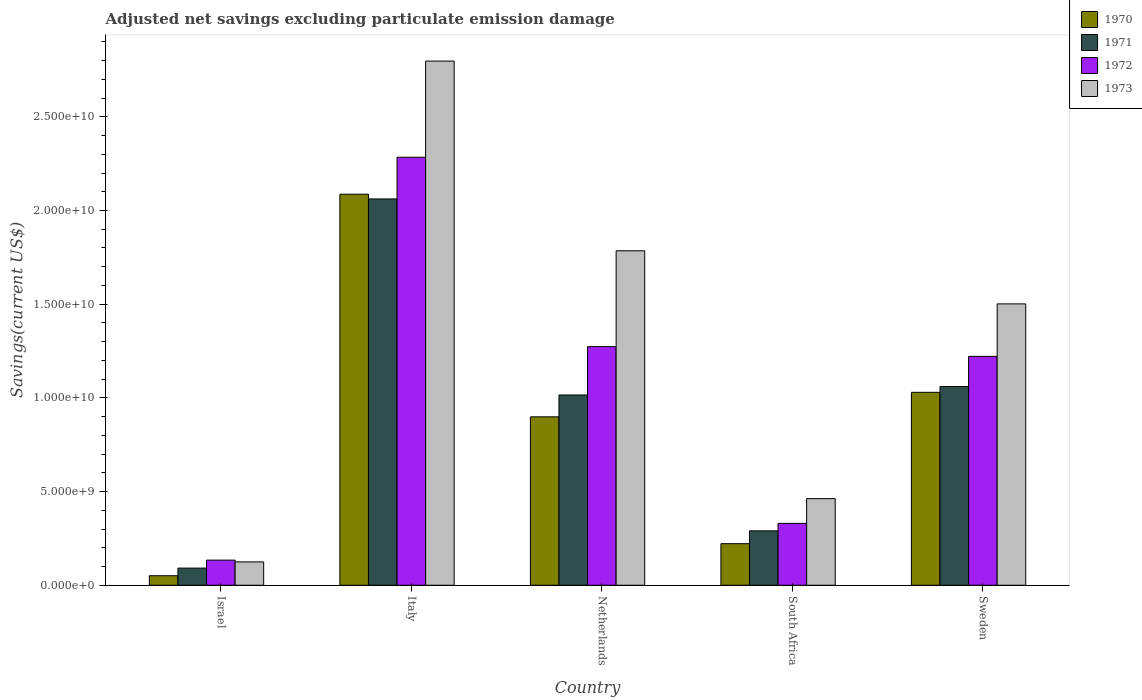How many different coloured bars are there?
Your answer should be compact. 4. How many groups of bars are there?
Your response must be concise. 5. Are the number of bars on each tick of the X-axis equal?
Make the answer very short. Yes. How many bars are there on the 1st tick from the left?
Provide a short and direct response. 4. How many bars are there on the 5th tick from the right?
Offer a very short reply. 4. What is the adjusted net savings in 1972 in South Africa?
Keep it short and to the point. 3.30e+09. Across all countries, what is the maximum adjusted net savings in 1971?
Your answer should be very brief. 2.06e+1. Across all countries, what is the minimum adjusted net savings in 1972?
Provide a short and direct response. 1.34e+09. In which country was the adjusted net savings in 1970 maximum?
Make the answer very short. Italy. In which country was the adjusted net savings in 1973 minimum?
Offer a terse response. Israel. What is the total adjusted net savings in 1972 in the graph?
Provide a short and direct response. 5.24e+1. What is the difference between the adjusted net savings in 1971 in Israel and that in Italy?
Make the answer very short. -1.97e+1. What is the difference between the adjusted net savings in 1970 in Sweden and the adjusted net savings in 1971 in Netherlands?
Ensure brevity in your answer.  1.43e+08. What is the average adjusted net savings in 1970 per country?
Make the answer very short. 8.58e+09. What is the difference between the adjusted net savings of/in 1972 and adjusted net savings of/in 1973 in Italy?
Your answer should be compact. -5.13e+09. In how many countries, is the adjusted net savings in 1970 greater than 13000000000 US$?
Ensure brevity in your answer.  1. What is the ratio of the adjusted net savings in 1970 in Italy to that in Sweden?
Your answer should be compact. 2.03. Is the difference between the adjusted net savings in 1972 in Italy and Sweden greater than the difference between the adjusted net savings in 1973 in Italy and Sweden?
Your answer should be compact. No. What is the difference between the highest and the second highest adjusted net savings in 1972?
Provide a succinct answer. -1.06e+1. What is the difference between the highest and the lowest adjusted net savings in 1973?
Offer a terse response. 2.67e+1. Is the sum of the adjusted net savings in 1972 in Italy and South Africa greater than the maximum adjusted net savings in 1971 across all countries?
Your response must be concise. Yes. Is it the case that in every country, the sum of the adjusted net savings in 1972 and adjusted net savings in 1970 is greater than the sum of adjusted net savings in 1973 and adjusted net savings in 1971?
Provide a succinct answer. No. What does the 3rd bar from the right in Israel represents?
Provide a short and direct response. 1971. How many bars are there?
Provide a succinct answer. 20. How many countries are there in the graph?
Ensure brevity in your answer.  5. What is the difference between two consecutive major ticks on the Y-axis?
Provide a short and direct response. 5.00e+09. Does the graph contain any zero values?
Provide a succinct answer. No. What is the title of the graph?
Make the answer very short. Adjusted net savings excluding particulate emission damage. Does "2001" appear as one of the legend labels in the graph?
Your response must be concise. No. What is the label or title of the Y-axis?
Make the answer very short. Savings(current US$). What is the Savings(current US$) in 1970 in Israel?
Give a very brief answer. 5.08e+08. What is the Savings(current US$) of 1971 in Israel?
Make the answer very short. 9.14e+08. What is the Savings(current US$) in 1972 in Israel?
Provide a short and direct response. 1.34e+09. What is the Savings(current US$) in 1973 in Israel?
Your answer should be very brief. 1.25e+09. What is the Savings(current US$) of 1970 in Italy?
Provide a succinct answer. 2.09e+1. What is the Savings(current US$) in 1971 in Italy?
Ensure brevity in your answer.  2.06e+1. What is the Savings(current US$) of 1972 in Italy?
Your response must be concise. 2.28e+1. What is the Savings(current US$) in 1973 in Italy?
Your answer should be very brief. 2.80e+1. What is the Savings(current US$) in 1970 in Netherlands?
Provide a short and direct response. 8.99e+09. What is the Savings(current US$) of 1971 in Netherlands?
Provide a succinct answer. 1.02e+1. What is the Savings(current US$) in 1972 in Netherlands?
Make the answer very short. 1.27e+1. What is the Savings(current US$) in 1973 in Netherlands?
Your answer should be very brief. 1.79e+1. What is the Savings(current US$) in 1970 in South Africa?
Keep it short and to the point. 2.22e+09. What is the Savings(current US$) in 1971 in South Africa?
Offer a terse response. 2.90e+09. What is the Savings(current US$) of 1972 in South Africa?
Make the answer very short. 3.30e+09. What is the Savings(current US$) of 1973 in South Africa?
Offer a very short reply. 4.62e+09. What is the Savings(current US$) of 1970 in Sweden?
Offer a terse response. 1.03e+1. What is the Savings(current US$) in 1971 in Sweden?
Offer a very short reply. 1.06e+1. What is the Savings(current US$) in 1972 in Sweden?
Make the answer very short. 1.22e+1. What is the Savings(current US$) in 1973 in Sweden?
Offer a very short reply. 1.50e+1. Across all countries, what is the maximum Savings(current US$) of 1970?
Provide a succinct answer. 2.09e+1. Across all countries, what is the maximum Savings(current US$) of 1971?
Your answer should be very brief. 2.06e+1. Across all countries, what is the maximum Savings(current US$) of 1972?
Offer a very short reply. 2.28e+1. Across all countries, what is the maximum Savings(current US$) in 1973?
Give a very brief answer. 2.80e+1. Across all countries, what is the minimum Savings(current US$) in 1970?
Provide a succinct answer. 5.08e+08. Across all countries, what is the minimum Savings(current US$) of 1971?
Provide a succinct answer. 9.14e+08. Across all countries, what is the minimum Savings(current US$) in 1972?
Your response must be concise. 1.34e+09. Across all countries, what is the minimum Savings(current US$) in 1973?
Your answer should be compact. 1.25e+09. What is the total Savings(current US$) in 1970 in the graph?
Your response must be concise. 4.29e+1. What is the total Savings(current US$) of 1971 in the graph?
Provide a short and direct response. 4.52e+1. What is the total Savings(current US$) in 1972 in the graph?
Ensure brevity in your answer.  5.24e+1. What is the total Savings(current US$) of 1973 in the graph?
Provide a short and direct response. 6.67e+1. What is the difference between the Savings(current US$) of 1970 in Israel and that in Italy?
Ensure brevity in your answer.  -2.04e+1. What is the difference between the Savings(current US$) in 1971 in Israel and that in Italy?
Keep it short and to the point. -1.97e+1. What is the difference between the Savings(current US$) of 1972 in Israel and that in Italy?
Your response must be concise. -2.15e+1. What is the difference between the Savings(current US$) of 1973 in Israel and that in Italy?
Provide a short and direct response. -2.67e+1. What is the difference between the Savings(current US$) of 1970 in Israel and that in Netherlands?
Offer a very short reply. -8.48e+09. What is the difference between the Savings(current US$) of 1971 in Israel and that in Netherlands?
Your response must be concise. -9.24e+09. What is the difference between the Savings(current US$) of 1972 in Israel and that in Netherlands?
Offer a very short reply. -1.14e+1. What is the difference between the Savings(current US$) in 1973 in Israel and that in Netherlands?
Your answer should be very brief. -1.66e+1. What is the difference between the Savings(current US$) of 1970 in Israel and that in South Africa?
Your response must be concise. -1.71e+09. What is the difference between the Savings(current US$) of 1971 in Israel and that in South Africa?
Provide a succinct answer. -1.99e+09. What is the difference between the Savings(current US$) of 1972 in Israel and that in South Africa?
Offer a terse response. -1.96e+09. What is the difference between the Savings(current US$) of 1973 in Israel and that in South Africa?
Make the answer very short. -3.38e+09. What is the difference between the Savings(current US$) in 1970 in Israel and that in Sweden?
Provide a short and direct response. -9.79e+09. What is the difference between the Savings(current US$) of 1971 in Israel and that in Sweden?
Your answer should be very brief. -9.69e+09. What is the difference between the Savings(current US$) in 1972 in Israel and that in Sweden?
Offer a very short reply. -1.09e+1. What is the difference between the Savings(current US$) of 1973 in Israel and that in Sweden?
Provide a short and direct response. -1.38e+1. What is the difference between the Savings(current US$) of 1970 in Italy and that in Netherlands?
Provide a short and direct response. 1.19e+1. What is the difference between the Savings(current US$) in 1971 in Italy and that in Netherlands?
Your answer should be very brief. 1.05e+1. What is the difference between the Savings(current US$) in 1972 in Italy and that in Netherlands?
Your answer should be very brief. 1.01e+1. What is the difference between the Savings(current US$) of 1973 in Italy and that in Netherlands?
Offer a very short reply. 1.01e+1. What is the difference between the Savings(current US$) of 1970 in Italy and that in South Africa?
Keep it short and to the point. 1.87e+1. What is the difference between the Savings(current US$) of 1971 in Italy and that in South Africa?
Ensure brevity in your answer.  1.77e+1. What is the difference between the Savings(current US$) of 1972 in Italy and that in South Africa?
Your answer should be compact. 1.95e+1. What is the difference between the Savings(current US$) of 1973 in Italy and that in South Africa?
Offer a very short reply. 2.34e+1. What is the difference between the Savings(current US$) in 1970 in Italy and that in Sweden?
Your response must be concise. 1.06e+1. What is the difference between the Savings(current US$) of 1971 in Italy and that in Sweden?
Your response must be concise. 1.00e+1. What is the difference between the Savings(current US$) in 1972 in Italy and that in Sweden?
Offer a terse response. 1.06e+1. What is the difference between the Savings(current US$) of 1973 in Italy and that in Sweden?
Your response must be concise. 1.30e+1. What is the difference between the Savings(current US$) of 1970 in Netherlands and that in South Africa?
Your response must be concise. 6.77e+09. What is the difference between the Savings(current US$) in 1971 in Netherlands and that in South Africa?
Your answer should be compact. 7.25e+09. What is the difference between the Savings(current US$) of 1972 in Netherlands and that in South Africa?
Your response must be concise. 9.43e+09. What is the difference between the Savings(current US$) of 1973 in Netherlands and that in South Africa?
Your answer should be compact. 1.32e+1. What is the difference between the Savings(current US$) of 1970 in Netherlands and that in Sweden?
Your response must be concise. -1.31e+09. What is the difference between the Savings(current US$) in 1971 in Netherlands and that in Sweden?
Keep it short and to the point. -4.54e+08. What is the difference between the Savings(current US$) of 1972 in Netherlands and that in Sweden?
Offer a very short reply. 5.20e+08. What is the difference between the Savings(current US$) of 1973 in Netherlands and that in Sweden?
Offer a very short reply. 2.83e+09. What is the difference between the Savings(current US$) in 1970 in South Africa and that in Sweden?
Your response must be concise. -8.08e+09. What is the difference between the Savings(current US$) of 1971 in South Africa and that in Sweden?
Keep it short and to the point. -7.70e+09. What is the difference between the Savings(current US$) of 1972 in South Africa and that in Sweden?
Give a very brief answer. -8.91e+09. What is the difference between the Savings(current US$) of 1973 in South Africa and that in Sweden?
Provide a succinct answer. -1.04e+1. What is the difference between the Savings(current US$) of 1970 in Israel and the Savings(current US$) of 1971 in Italy?
Offer a terse response. -2.01e+1. What is the difference between the Savings(current US$) in 1970 in Israel and the Savings(current US$) in 1972 in Italy?
Your answer should be compact. -2.23e+1. What is the difference between the Savings(current US$) in 1970 in Israel and the Savings(current US$) in 1973 in Italy?
Ensure brevity in your answer.  -2.75e+1. What is the difference between the Savings(current US$) in 1971 in Israel and the Savings(current US$) in 1972 in Italy?
Offer a terse response. -2.19e+1. What is the difference between the Savings(current US$) of 1971 in Israel and the Savings(current US$) of 1973 in Italy?
Your answer should be compact. -2.71e+1. What is the difference between the Savings(current US$) of 1972 in Israel and the Savings(current US$) of 1973 in Italy?
Give a very brief answer. -2.66e+1. What is the difference between the Savings(current US$) in 1970 in Israel and the Savings(current US$) in 1971 in Netherlands?
Provide a succinct answer. -9.65e+09. What is the difference between the Savings(current US$) of 1970 in Israel and the Savings(current US$) of 1972 in Netherlands?
Your response must be concise. -1.22e+1. What is the difference between the Savings(current US$) of 1970 in Israel and the Savings(current US$) of 1973 in Netherlands?
Offer a very short reply. -1.73e+1. What is the difference between the Savings(current US$) in 1971 in Israel and the Savings(current US$) in 1972 in Netherlands?
Your answer should be very brief. -1.18e+1. What is the difference between the Savings(current US$) of 1971 in Israel and the Savings(current US$) of 1973 in Netherlands?
Keep it short and to the point. -1.69e+1. What is the difference between the Savings(current US$) of 1972 in Israel and the Savings(current US$) of 1973 in Netherlands?
Provide a short and direct response. -1.65e+1. What is the difference between the Savings(current US$) in 1970 in Israel and the Savings(current US$) in 1971 in South Africa?
Make the answer very short. -2.39e+09. What is the difference between the Savings(current US$) in 1970 in Israel and the Savings(current US$) in 1972 in South Africa?
Give a very brief answer. -2.79e+09. What is the difference between the Savings(current US$) of 1970 in Israel and the Savings(current US$) of 1973 in South Africa?
Give a very brief answer. -4.11e+09. What is the difference between the Savings(current US$) of 1971 in Israel and the Savings(current US$) of 1972 in South Africa?
Provide a succinct answer. -2.39e+09. What is the difference between the Savings(current US$) in 1971 in Israel and the Savings(current US$) in 1973 in South Africa?
Provide a succinct answer. -3.71e+09. What is the difference between the Savings(current US$) of 1972 in Israel and the Savings(current US$) of 1973 in South Africa?
Ensure brevity in your answer.  -3.28e+09. What is the difference between the Savings(current US$) in 1970 in Israel and the Savings(current US$) in 1971 in Sweden?
Your response must be concise. -1.01e+1. What is the difference between the Savings(current US$) of 1970 in Israel and the Savings(current US$) of 1972 in Sweden?
Make the answer very short. -1.17e+1. What is the difference between the Savings(current US$) of 1970 in Israel and the Savings(current US$) of 1973 in Sweden?
Your response must be concise. -1.45e+1. What is the difference between the Savings(current US$) in 1971 in Israel and the Savings(current US$) in 1972 in Sweden?
Keep it short and to the point. -1.13e+1. What is the difference between the Savings(current US$) in 1971 in Israel and the Savings(current US$) in 1973 in Sweden?
Ensure brevity in your answer.  -1.41e+1. What is the difference between the Savings(current US$) of 1972 in Israel and the Savings(current US$) of 1973 in Sweden?
Give a very brief answer. -1.37e+1. What is the difference between the Savings(current US$) in 1970 in Italy and the Savings(current US$) in 1971 in Netherlands?
Offer a terse response. 1.07e+1. What is the difference between the Savings(current US$) of 1970 in Italy and the Savings(current US$) of 1972 in Netherlands?
Offer a terse response. 8.14e+09. What is the difference between the Savings(current US$) of 1970 in Italy and the Savings(current US$) of 1973 in Netherlands?
Offer a terse response. 3.02e+09. What is the difference between the Savings(current US$) in 1971 in Italy and the Savings(current US$) in 1972 in Netherlands?
Make the answer very short. 7.88e+09. What is the difference between the Savings(current US$) in 1971 in Italy and the Savings(current US$) in 1973 in Netherlands?
Offer a very short reply. 2.77e+09. What is the difference between the Savings(current US$) of 1972 in Italy and the Savings(current US$) of 1973 in Netherlands?
Make the answer very short. 4.99e+09. What is the difference between the Savings(current US$) in 1970 in Italy and the Savings(current US$) in 1971 in South Africa?
Offer a terse response. 1.80e+1. What is the difference between the Savings(current US$) in 1970 in Italy and the Savings(current US$) in 1972 in South Africa?
Keep it short and to the point. 1.76e+1. What is the difference between the Savings(current US$) of 1970 in Italy and the Savings(current US$) of 1973 in South Africa?
Offer a terse response. 1.62e+1. What is the difference between the Savings(current US$) of 1971 in Italy and the Savings(current US$) of 1972 in South Africa?
Your answer should be compact. 1.73e+1. What is the difference between the Savings(current US$) in 1971 in Italy and the Savings(current US$) in 1973 in South Africa?
Keep it short and to the point. 1.60e+1. What is the difference between the Savings(current US$) in 1972 in Italy and the Savings(current US$) in 1973 in South Africa?
Offer a very short reply. 1.82e+1. What is the difference between the Savings(current US$) of 1970 in Italy and the Savings(current US$) of 1971 in Sweden?
Your response must be concise. 1.03e+1. What is the difference between the Savings(current US$) of 1970 in Italy and the Savings(current US$) of 1972 in Sweden?
Provide a succinct answer. 8.66e+09. What is the difference between the Savings(current US$) in 1970 in Italy and the Savings(current US$) in 1973 in Sweden?
Give a very brief answer. 5.85e+09. What is the difference between the Savings(current US$) of 1971 in Italy and the Savings(current US$) of 1972 in Sweden?
Offer a terse response. 8.40e+09. What is the difference between the Savings(current US$) of 1971 in Italy and the Savings(current US$) of 1973 in Sweden?
Offer a terse response. 5.60e+09. What is the difference between the Savings(current US$) in 1972 in Italy and the Savings(current US$) in 1973 in Sweden?
Make the answer very short. 7.83e+09. What is the difference between the Savings(current US$) in 1970 in Netherlands and the Savings(current US$) in 1971 in South Africa?
Make the answer very short. 6.09e+09. What is the difference between the Savings(current US$) in 1970 in Netherlands and the Savings(current US$) in 1972 in South Africa?
Offer a terse response. 5.69e+09. What is the difference between the Savings(current US$) of 1970 in Netherlands and the Savings(current US$) of 1973 in South Africa?
Your answer should be compact. 4.37e+09. What is the difference between the Savings(current US$) in 1971 in Netherlands and the Savings(current US$) in 1972 in South Africa?
Make the answer very short. 6.85e+09. What is the difference between the Savings(current US$) of 1971 in Netherlands and the Savings(current US$) of 1973 in South Africa?
Make the answer very short. 5.53e+09. What is the difference between the Savings(current US$) of 1972 in Netherlands and the Savings(current US$) of 1973 in South Africa?
Provide a succinct answer. 8.11e+09. What is the difference between the Savings(current US$) in 1970 in Netherlands and the Savings(current US$) in 1971 in Sweden?
Make the answer very short. -1.62e+09. What is the difference between the Savings(current US$) in 1970 in Netherlands and the Savings(current US$) in 1972 in Sweden?
Provide a succinct answer. -3.23e+09. What is the difference between the Savings(current US$) of 1970 in Netherlands and the Savings(current US$) of 1973 in Sweden?
Provide a succinct answer. -6.03e+09. What is the difference between the Savings(current US$) of 1971 in Netherlands and the Savings(current US$) of 1972 in Sweden?
Your answer should be compact. -2.06e+09. What is the difference between the Savings(current US$) in 1971 in Netherlands and the Savings(current US$) in 1973 in Sweden?
Offer a very short reply. -4.86e+09. What is the difference between the Savings(current US$) of 1972 in Netherlands and the Savings(current US$) of 1973 in Sweden?
Keep it short and to the point. -2.28e+09. What is the difference between the Savings(current US$) of 1970 in South Africa and the Savings(current US$) of 1971 in Sweden?
Keep it short and to the point. -8.39e+09. What is the difference between the Savings(current US$) of 1970 in South Africa and the Savings(current US$) of 1972 in Sweden?
Make the answer very short. -1.00e+1. What is the difference between the Savings(current US$) of 1970 in South Africa and the Savings(current US$) of 1973 in Sweden?
Give a very brief answer. -1.28e+1. What is the difference between the Savings(current US$) in 1971 in South Africa and the Savings(current US$) in 1972 in Sweden?
Provide a succinct answer. -9.31e+09. What is the difference between the Savings(current US$) in 1971 in South Africa and the Savings(current US$) in 1973 in Sweden?
Offer a very short reply. -1.21e+1. What is the difference between the Savings(current US$) of 1972 in South Africa and the Savings(current US$) of 1973 in Sweden?
Your answer should be compact. -1.17e+1. What is the average Savings(current US$) in 1970 per country?
Provide a short and direct response. 8.58e+09. What is the average Savings(current US$) in 1971 per country?
Provide a succinct answer. 9.04e+09. What is the average Savings(current US$) in 1972 per country?
Keep it short and to the point. 1.05e+1. What is the average Savings(current US$) of 1973 per country?
Your answer should be very brief. 1.33e+1. What is the difference between the Savings(current US$) of 1970 and Savings(current US$) of 1971 in Israel?
Provide a succinct answer. -4.06e+08. What is the difference between the Savings(current US$) in 1970 and Savings(current US$) in 1972 in Israel?
Offer a terse response. -8.33e+08. What is the difference between the Savings(current US$) of 1970 and Savings(current US$) of 1973 in Israel?
Your answer should be compact. -7.39e+08. What is the difference between the Savings(current US$) in 1971 and Savings(current US$) in 1972 in Israel?
Give a very brief answer. -4.27e+08. What is the difference between the Savings(current US$) in 1971 and Savings(current US$) in 1973 in Israel?
Your answer should be very brief. -3.33e+08. What is the difference between the Savings(current US$) in 1972 and Savings(current US$) in 1973 in Israel?
Offer a terse response. 9.40e+07. What is the difference between the Savings(current US$) in 1970 and Savings(current US$) in 1971 in Italy?
Provide a short and direct response. 2.53e+08. What is the difference between the Savings(current US$) in 1970 and Savings(current US$) in 1972 in Italy?
Provide a short and direct response. -1.97e+09. What is the difference between the Savings(current US$) in 1970 and Savings(current US$) in 1973 in Italy?
Your answer should be compact. -7.11e+09. What is the difference between the Savings(current US$) of 1971 and Savings(current US$) of 1972 in Italy?
Ensure brevity in your answer.  -2.23e+09. What is the difference between the Savings(current US$) in 1971 and Savings(current US$) in 1973 in Italy?
Offer a very short reply. -7.36e+09. What is the difference between the Savings(current US$) of 1972 and Savings(current US$) of 1973 in Italy?
Your answer should be very brief. -5.13e+09. What is the difference between the Savings(current US$) in 1970 and Savings(current US$) in 1971 in Netherlands?
Provide a short and direct response. -1.17e+09. What is the difference between the Savings(current US$) in 1970 and Savings(current US$) in 1972 in Netherlands?
Ensure brevity in your answer.  -3.75e+09. What is the difference between the Savings(current US$) of 1970 and Savings(current US$) of 1973 in Netherlands?
Your answer should be compact. -8.86e+09. What is the difference between the Savings(current US$) in 1971 and Savings(current US$) in 1972 in Netherlands?
Your answer should be very brief. -2.58e+09. What is the difference between the Savings(current US$) in 1971 and Savings(current US$) in 1973 in Netherlands?
Your answer should be compact. -7.70e+09. What is the difference between the Savings(current US$) of 1972 and Savings(current US$) of 1973 in Netherlands?
Give a very brief answer. -5.11e+09. What is the difference between the Savings(current US$) in 1970 and Savings(current US$) in 1971 in South Africa?
Provide a succinct answer. -6.85e+08. What is the difference between the Savings(current US$) of 1970 and Savings(current US$) of 1972 in South Africa?
Keep it short and to the point. -1.08e+09. What is the difference between the Savings(current US$) in 1970 and Savings(current US$) in 1973 in South Africa?
Keep it short and to the point. -2.40e+09. What is the difference between the Savings(current US$) in 1971 and Savings(current US$) in 1972 in South Africa?
Make the answer very short. -4.00e+08. What is the difference between the Savings(current US$) in 1971 and Savings(current US$) in 1973 in South Africa?
Make the answer very short. -1.72e+09. What is the difference between the Savings(current US$) in 1972 and Savings(current US$) in 1973 in South Africa?
Your answer should be compact. -1.32e+09. What is the difference between the Savings(current US$) of 1970 and Savings(current US$) of 1971 in Sweden?
Keep it short and to the point. -3.10e+08. What is the difference between the Savings(current US$) of 1970 and Savings(current US$) of 1972 in Sweden?
Your response must be concise. -1.92e+09. What is the difference between the Savings(current US$) of 1970 and Savings(current US$) of 1973 in Sweden?
Provide a succinct answer. -4.72e+09. What is the difference between the Savings(current US$) in 1971 and Savings(current US$) in 1972 in Sweden?
Ensure brevity in your answer.  -1.61e+09. What is the difference between the Savings(current US$) in 1971 and Savings(current US$) in 1973 in Sweden?
Offer a very short reply. -4.41e+09. What is the difference between the Savings(current US$) of 1972 and Savings(current US$) of 1973 in Sweden?
Make the answer very short. -2.80e+09. What is the ratio of the Savings(current US$) in 1970 in Israel to that in Italy?
Keep it short and to the point. 0.02. What is the ratio of the Savings(current US$) in 1971 in Israel to that in Italy?
Your answer should be very brief. 0.04. What is the ratio of the Savings(current US$) of 1972 in Israel to that in Italy?
Your answer should be very brief. 0.06. What is the ratio of the Savings(current US$) of 1973 in Israel to that in Italy?
Keep it short and to the point. 0.04. What is the ratio of the Savings(current US$) of 1970 in Israel to that in Netherlands?
Give a very brief answer. 0.06. What is the ratio of the Savings(current US$) of 1971 in Israel to that in Netherlands?
Offer a very short reply. 0.09. What is the ratio of the Savings(current US$) of 1972 in Israel to that in Netherlands?
Your answer should be compact. 0.11. What is the ratio of the Savings(current US$) in 1973 in Israel to that in Netherlands?
Keep it short and to the point. 0.07. What is the ratio of the Savings(current US$) of 1970 in Israel to that in South Africa?
Give a very brief answer. 0.23. What is the ratio of the Savings(current US$) of 1971 in Israel to that in South Africa?
Offer a terse response. 0.32. What is the ratio of the Savings(current US$) in 1972 in Israel to that in South Africa?
Your response must be concise. 0.41. What is the ratio of the Savings(current US$) of 1973 in Israel to that in South Africa?
Your response must be concise. 0.27. What is the ratio of the Savings(current US$) in 1970 in Israel to that in Sweden?
Give a very brief answer. 0.05. What is the ratio of the Savings(current US$) in 1971 in Israel to that in Sweden?
Your answer should be compact. 0.09. What is the ratio of the Savings(current US$) of 1972 in Israel to that in Sweden?
Offer a terse response. 0.11. What is the ratio of the Savings(current US$) of 1973 in Israel to that in Sweden?
Your response must be concise. 0.08. What is the ratio of the Savings(current US$) of 1970 in Italy to that in Netherlands?
Keep it short and to the point. 2.32. What is the ratio of the Savings(current US$) in 1971 in Italy to that in Netherlands?
Provide a short and direct response. 2.03. What is the ratio of the Savings(current US$) of 1972 in Italy to that in Netherlands?
Your answer should be very brief. 1.79. What is the ratio of the Savings(current US$) in 1973 in Italy to that in Netherlands?
Your answer should be compact. 1.57. What is the ratio of the Savings(current US$) of 1970 in Italy to that in South Africa?
Provide a short and direct response. 9.41. What is the ratio of the Savings(current US$) of 1971 in Italy to that in South Africa?
Offer a terse response. 7.1. What is the ratio of the Savings(current US$) of 1972 in Italy to that in South Africa?
Your response must be concise. 6.92. What is the ratio of the Savings(current US$) of 1973 in Italy to that in South Africa?
Offer a very short reply. 6.05. What is the ratio of the Savings(current US$) of 1970 in Italy to that in Sweden?
Provide a short and direct response. 2.03. What is the ratio of the Savings(current US$) in 1971 in Italy to that in Sweden?
Your answer should be very brief. 1.94. What is the ratio of the Savings(current US$) in 1972 in Italy to that in Sweden?
Make the answer very short. 1.87. What is the ratio of the Savings(current US$) of 1973 in Italy to that in Sweden?
Your response must be concise. 1.86. What is the ratio of the Savings(current US$) in 1970 in Netherlands to that in South Africa?
Keep it short and to the point. 4.05. What is the ratio of the Savings(current US$) in 1971 in Netherlands to that in South Africa?
Keep it short and to the point. 3.5. What is the ratio of the Savings(current US$) in 1972 in Netherlands to that in South Africa?
Give a very brief answer. 3.86. What is the ratio of the Savings(current US$) in 1973 in Netherlands to that in South Africa?
Ensure brevity in your answer.  3.86. What is the ratio of the Savings(current US$) in 1970 in Netherlands to that in Sweden?
Your answer should be very brief. 0.87. What is the ratio of the Savings(current US$) of 1971 in Netherlands to that in Sweden?
Your response must be concise. 0.96. What is the ratio of the Savings(current US$) in 1972 in Netherlands to that in Sweden?
Your response must be concise. 1.04. What is the ratio of the Savings(current US$) of 1973 in Netherlands to that in Sweden?
Provide a short and direct response. 1.19. What is the ratio of the Savings(current US$) in 1970 in South Africa to that in Sweden?
Keep it short and to the point. 0.22. What is the ratio of the Savings(current US$) in 1971 in South Africa to that in Sweden?
Offer a very short reply. 0.27. What is the ratio of the Savings(current US$) of 1972 in South Africa to that in Sweden?
Offer a terse response. 0.27. What is the ratio of the Savings(current US$) of 1973 in South Africa to that in Sweden?
Provide a succinct answer. 0.31. What is the difference between the highest and the second highest Savings(current US$) of 1970?
Provide a short and direct response. 1.06e+1. What is the difference between the highest and the second highest Savings(current US$) of 1971?
Your answer should be very brief. 1.00e+1. What is the difference between the highest and the second highest Savings(current US$) of 1972?
Offer a terse response. 1.01e+1. What is the difference between the highest and the second highest Savings(current US$) in 1973?
Your answer should be very brief. 1.01e+1. What is the difference between the highest and the lowest Savings(current US$) in 1970?
Provide a short and direct response. 2.04e+1. What is the difference between the highest and the lowest Savings(current US$) in 1971?
Make the answer very short. 1.97e+1. What is the difference between the highest and the lowest Savings(current US$) of 1972?
Offer a terse response. 2.15e+1. What is the difference between the highest and the lowest Savings(current US$) in 1973?
Offer a very short reply. 2.67e+1. 